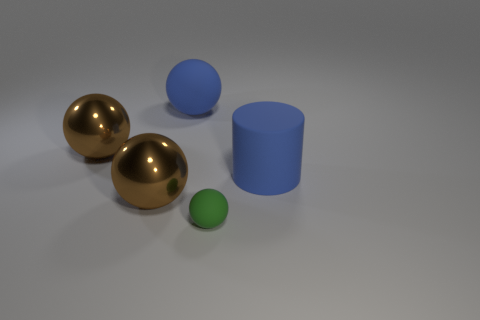Is there a matte thing of the same color as the tiny sphere? No, there is not. The tiny sphere appears to be uniquely colored in a matte finish, distinct from the other objects in the image which have a reflective surface and different hues. 